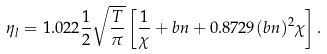Convert formula to latex. <formula><loc_0><loc_0><loc_500><loc_500>\eta _ { l } = 1 . 0 2 2 \frac { 1 } { 2 } \sqrt { \frac { T } { \pi } } \left [ \frac { 1 } { \chi } + b n + 0 . 8 7 2 9 ( b n ) ^ { 2 } \chi \right ] .</formula> 